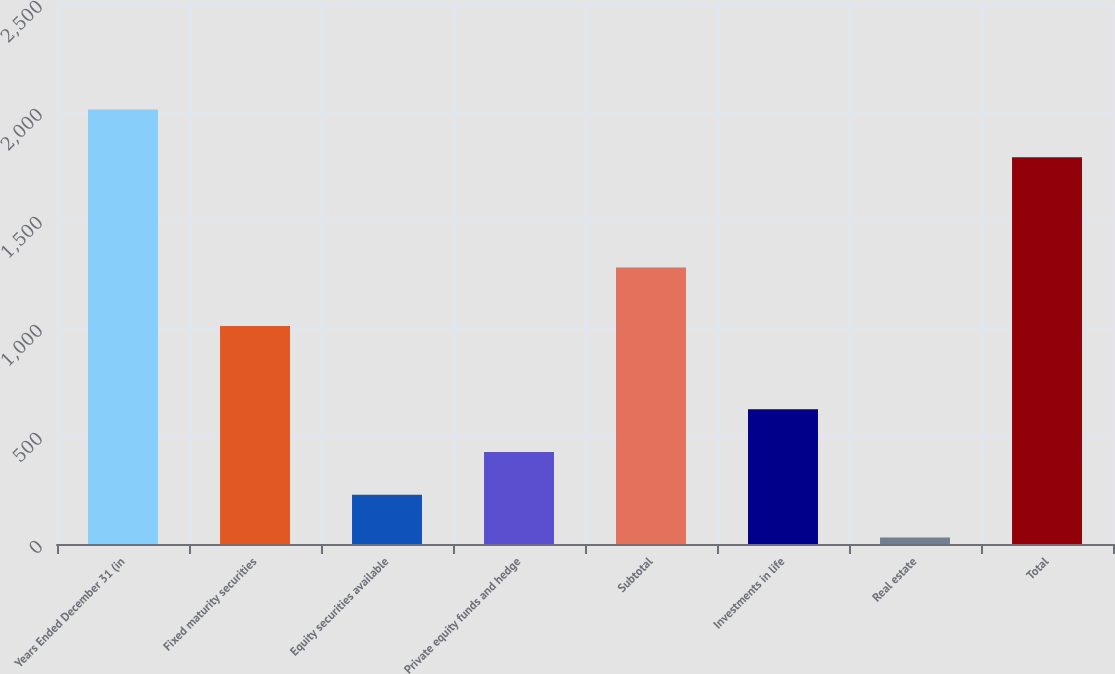<chart> <loc_0><loc_0><loc_500><loc_500><bar_chart><fcel>Years Ended December 31 (in<fcel>Fixed maturity securities<fcel>Equity securities available<fcel>Private equity funds and hedge<fcel>Subtotal<fcel>Investments in life<fcel>Real estate<fcel>Total<nl><fcel>2011<fcel>1009<fcel>228.1<fcel>426.2<fcel>1280<fcel>624.3<fcel>30<fcel>1790<nl></chart> 